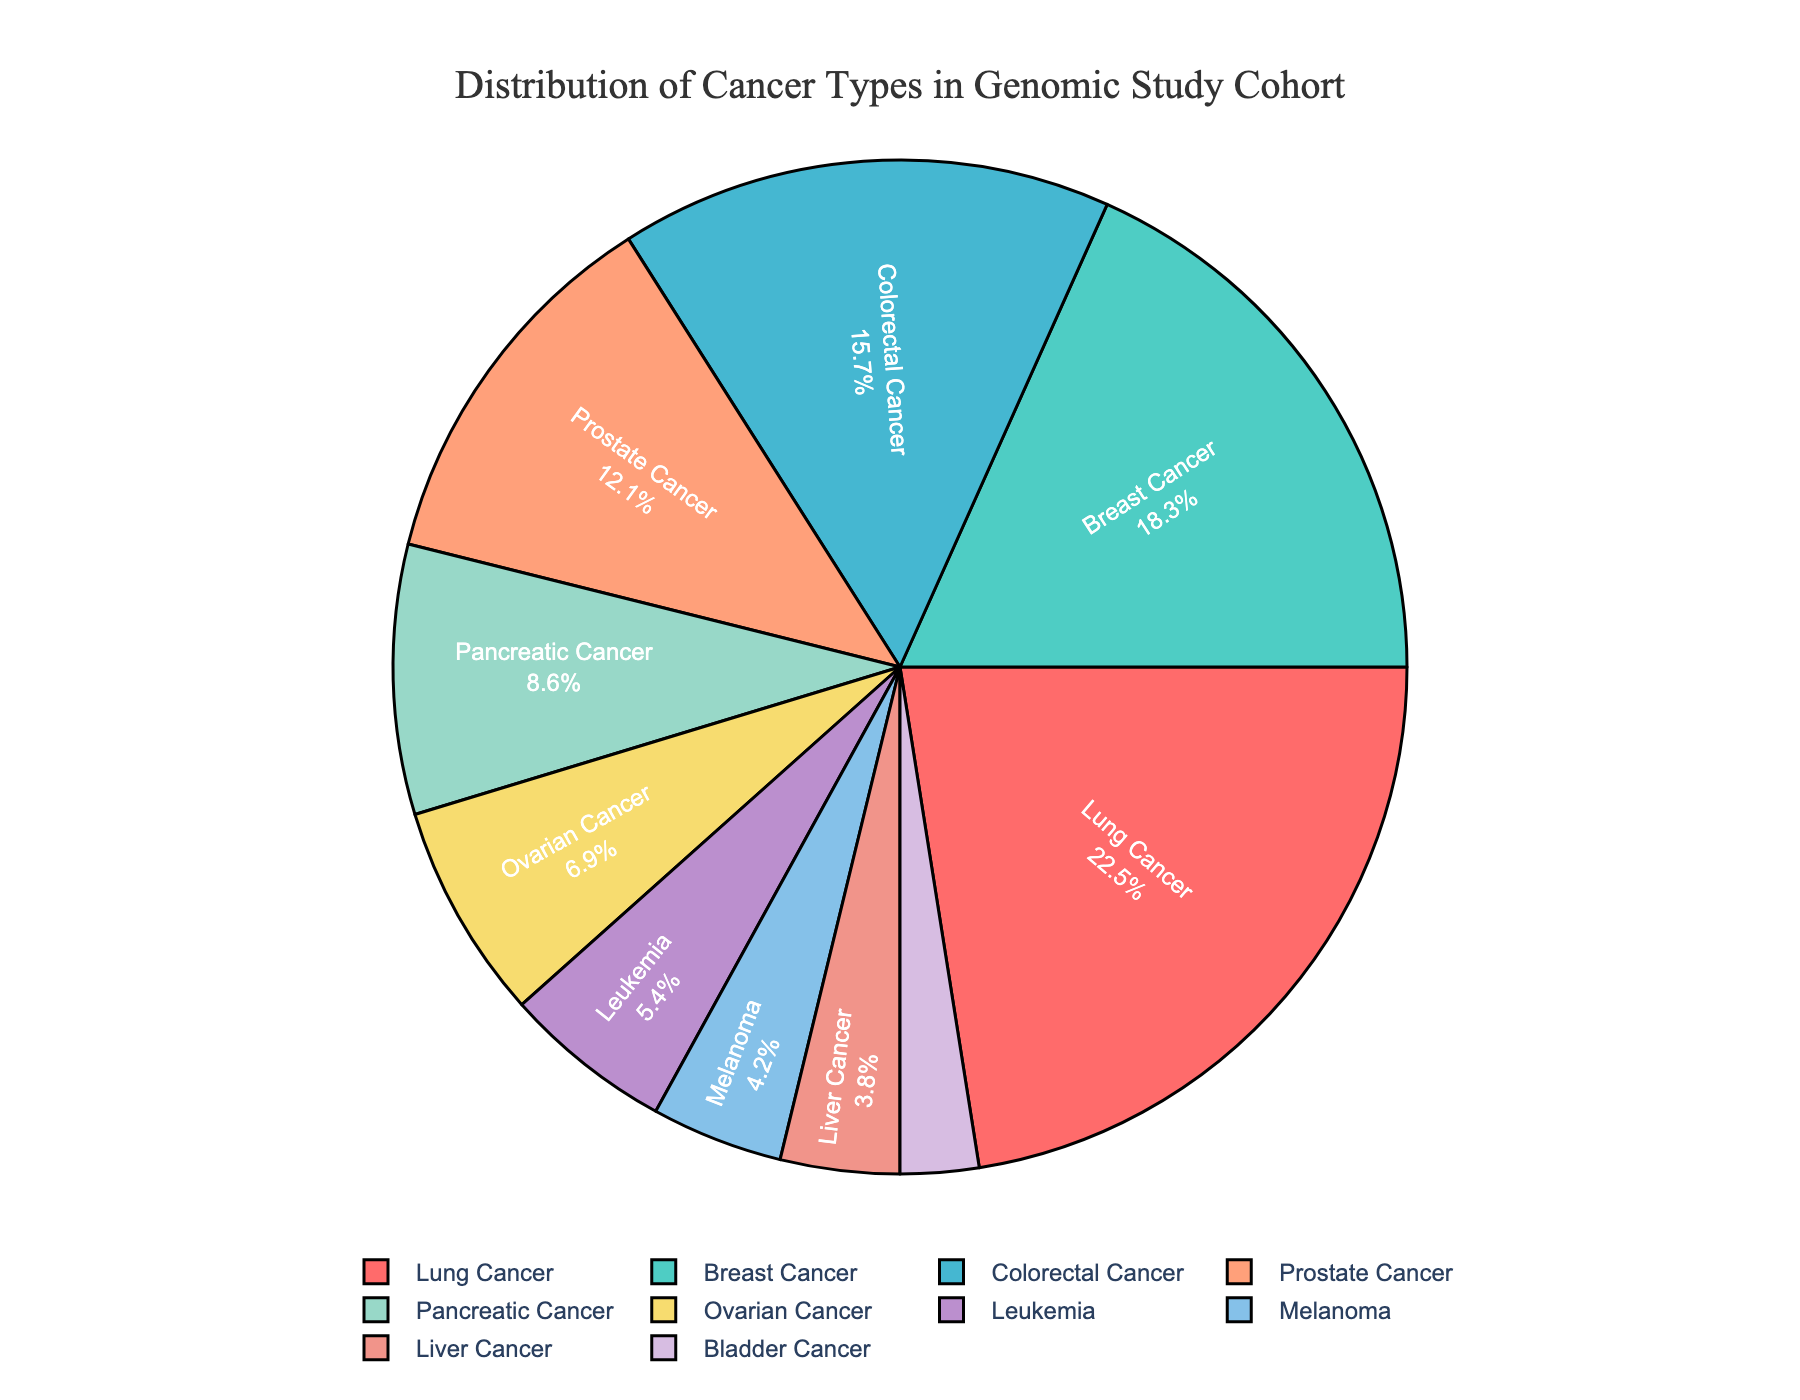What's the most common cancer type in this cohort? The largest section of the pie chart represents the most common cancer type. According to the data, Lung Cancer has the highest percentage.
Answer: Lung Cancer Which cancer type has the smallest representation in this cohort? The smallest section of the pie chart represents the least common cancer type. According to the data, Bladder Cancer has the lowest percentage.
Answer: Bladder Cancer What is the combined percentage of Lung Cancer and Breast Cancer? Sum the percentages of Lung Cancer (22.5%) and Breast Cancer (18.3%). 22.5 + 18.3 = 40.8
Answer: 40.8% How does the percentage of Colorectal Cancer compare to Prostate Cancer? Compare the percentages directly from the data. Colorectal Cancer is 15.7% and Prostate Cancer is 12.1%. Since 15.7 > 12.1, Colorectal Cancer has a higher percentage.
Answer: Colorectal Cancer is higher What's the total percentage of cancers that individually account for less than 10% each? Add the percentages of Pancreatic Cancer (8.6%), Ovarian Cancer (6.9%), Leukemia (5.4%), Melanoma (4.2%), Liver Cancer (3.8%), and Bladder Cancer (2.5%). 8.6 + 6.9 + 5.4 + 4.2 + 3.8 + 2.5 = 31.4
Answer: 31.4% Which cancer type is represented by the blue segment in the pie chart? Based on the custom color palette and given data, Breast Cancer is depicted in the chart using the second color, which is blue.
Answer: Breast Cancer How does the sum of percentages for Leukemia and Melanoma compare to Pancreatic Cancer? First, sum the percentages for Leukemia (5.4%) and Melanoma (4.2%) which equals 9.6%. Compare this sum to Pancreatic Cancer (8.6%). Since 9.6 > 8.6, the combined percentage for Leukemia and Melanoma is higher.
Answer: Leukemia and Melanoma are higher What's the difference in percentage between Liver Cancer and Ovarian Cancer? Subtract the percentage of Liver Cancer (3.8%) from Ovarian Cancer (6.9%). 6.9 - 3.8 = 3.1
Answer: 3.1% Which cancer types together account for about half of the cohort? Identify cancer types whose combined percentages approach 50%. Lung Cancer (22.5%) and Breast Cancer (18.3%) together account for 40.8%. Including Colorectal Cancer (15.7%) goes over 50%. So, Lung Cancer, Breast Cancer, and Colorectal Cancer together account for more than half.
Answer: Lung Cancer, Breast Cancer, and Colorectal Cancer 